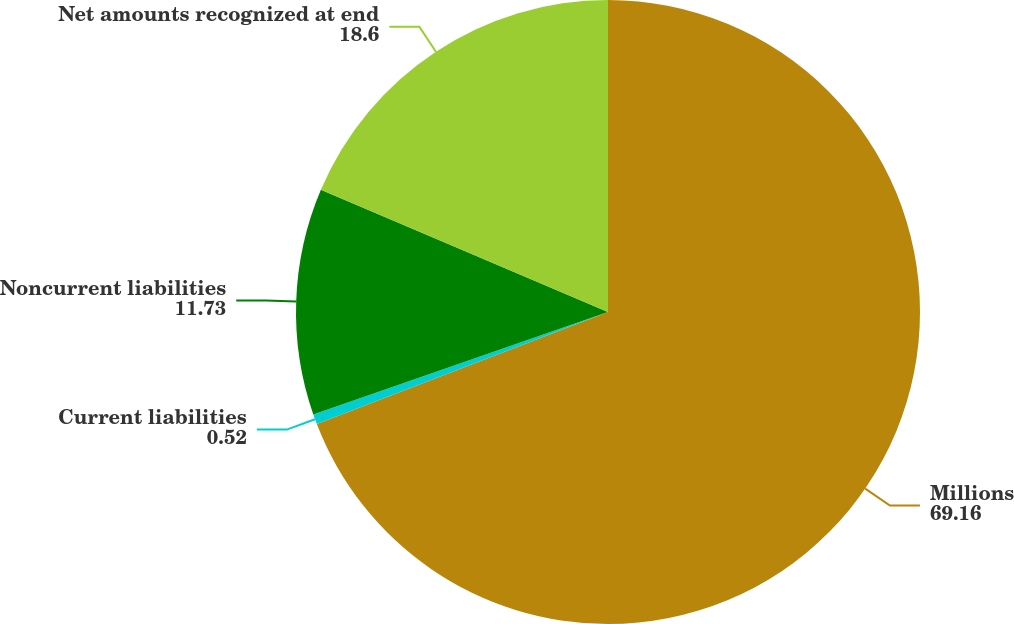Convert chart. <chart><loc_0><loc_0><loc_500><loc_500><pie_chart><fcel>Millions<fcel>Current liabilities<fcel>Noncurrent liabilities<fcel>Net amounts recognized at end<nl><fcel>69.16%<fcel>0.52%<fcel>11.73%<fcel>18.6%<nl></chart> 